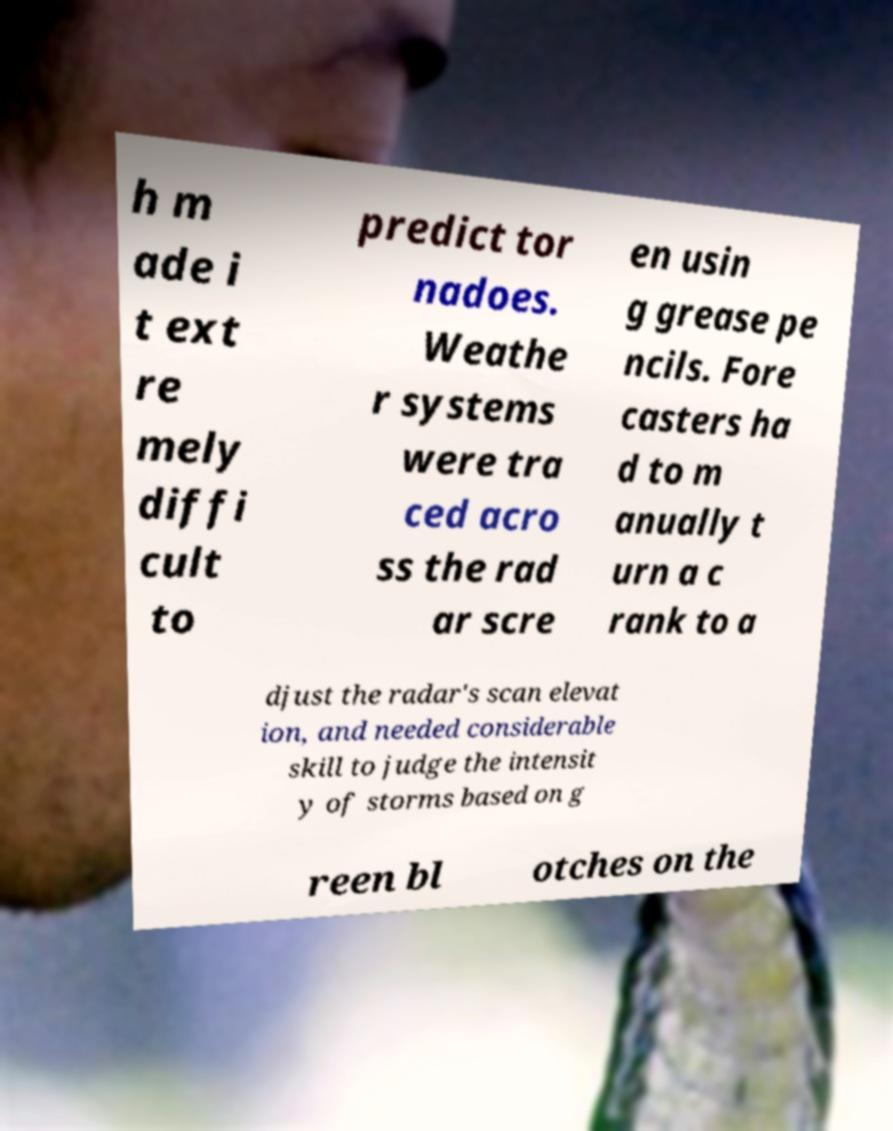Could you assist in decoding the text presented in this image and type it out clearly? h m ade i t ext re mely diffi cult to predict tor nadoes. Weathe r systems were tra ced acro ss the rad ar scre en usin g grease pe ncils. Fore casters ha d to m anually t urn a c rank to a djust the radar's scan elevat ion, and needed considerable skill to judge the intensit y of storms based on g reen bl otches on the 